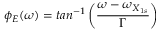Convert formula to latex. <formula><loc_0><loc_0><loc_500><loc_500>\phi _ { E } ( \omega ) = t a n ^ { - 1 } \left ( \frac { \omega - \omega _ { X _ { 1 s } } } { \Gamma } \right )</formula> 